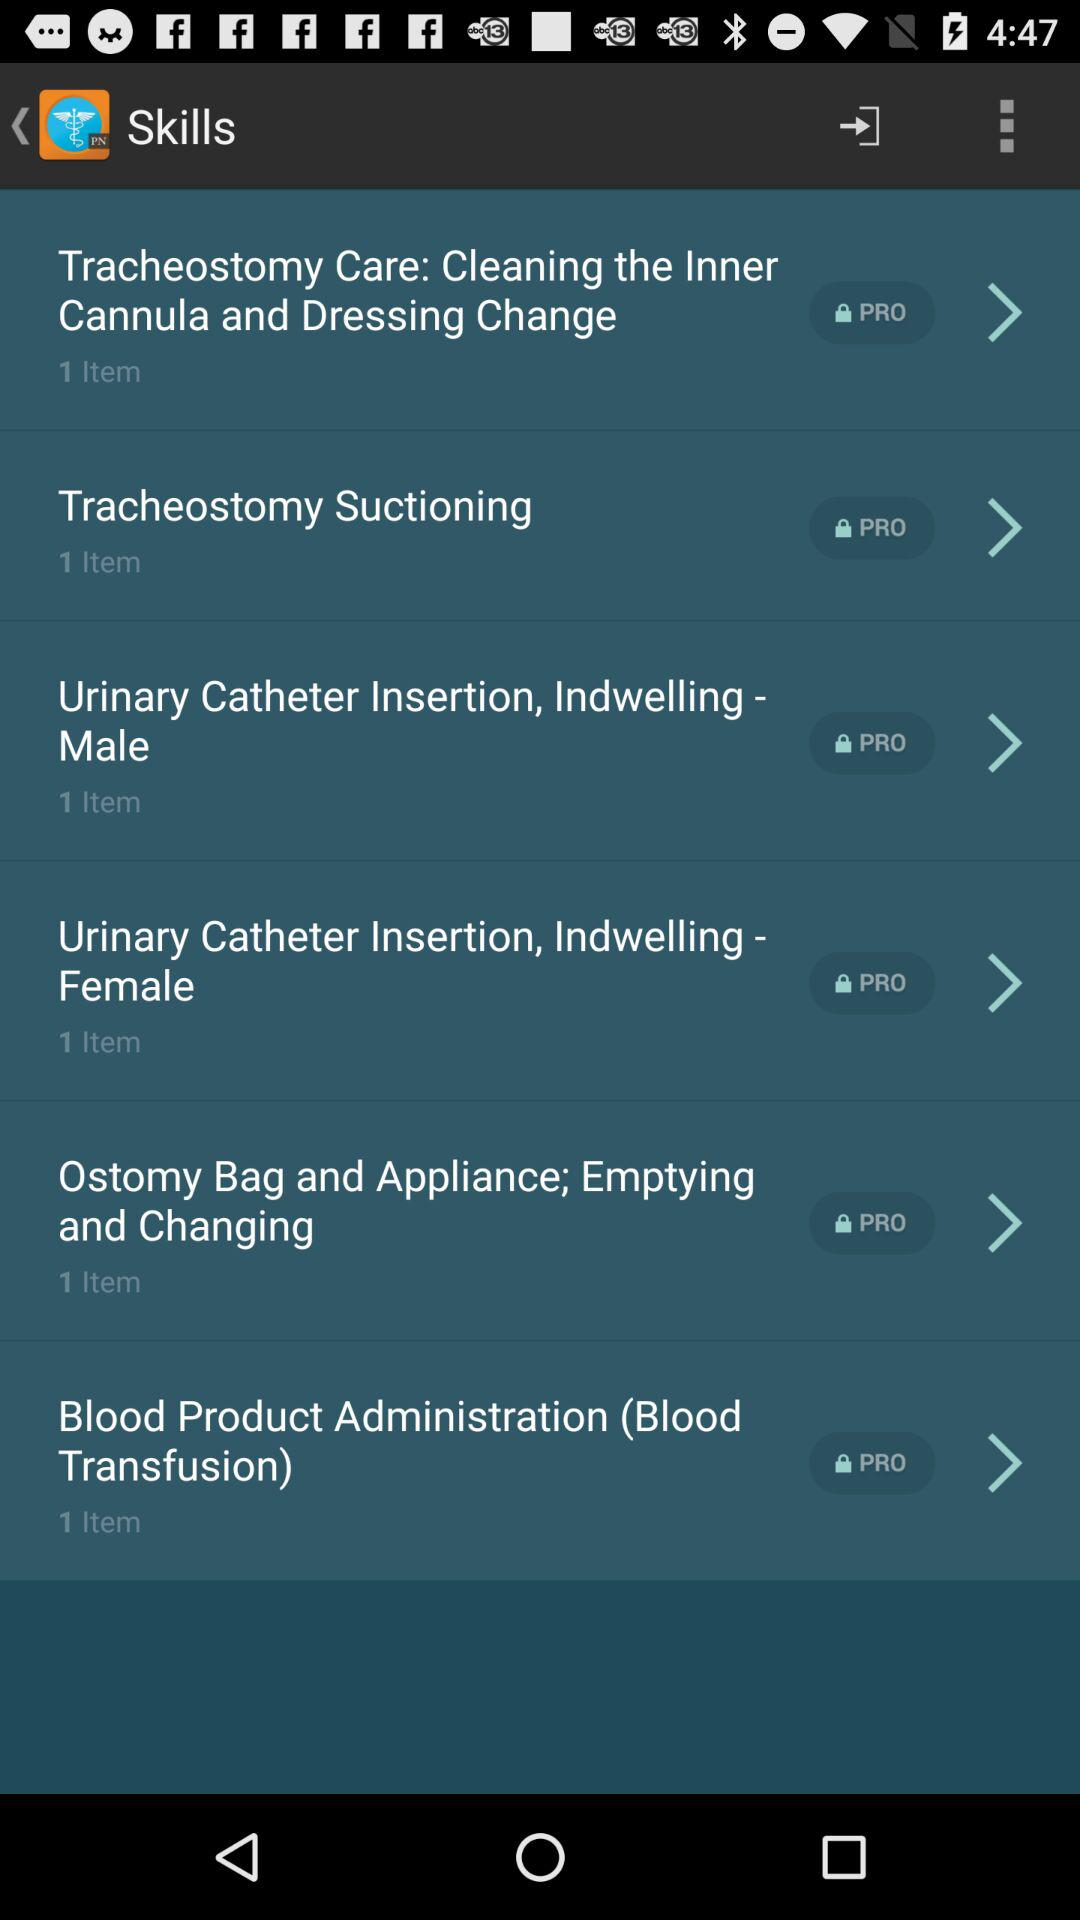How many items are in "Ostomy Bag and Appliance"? There is 1 item in "Ostomy Bag and Appliance". 